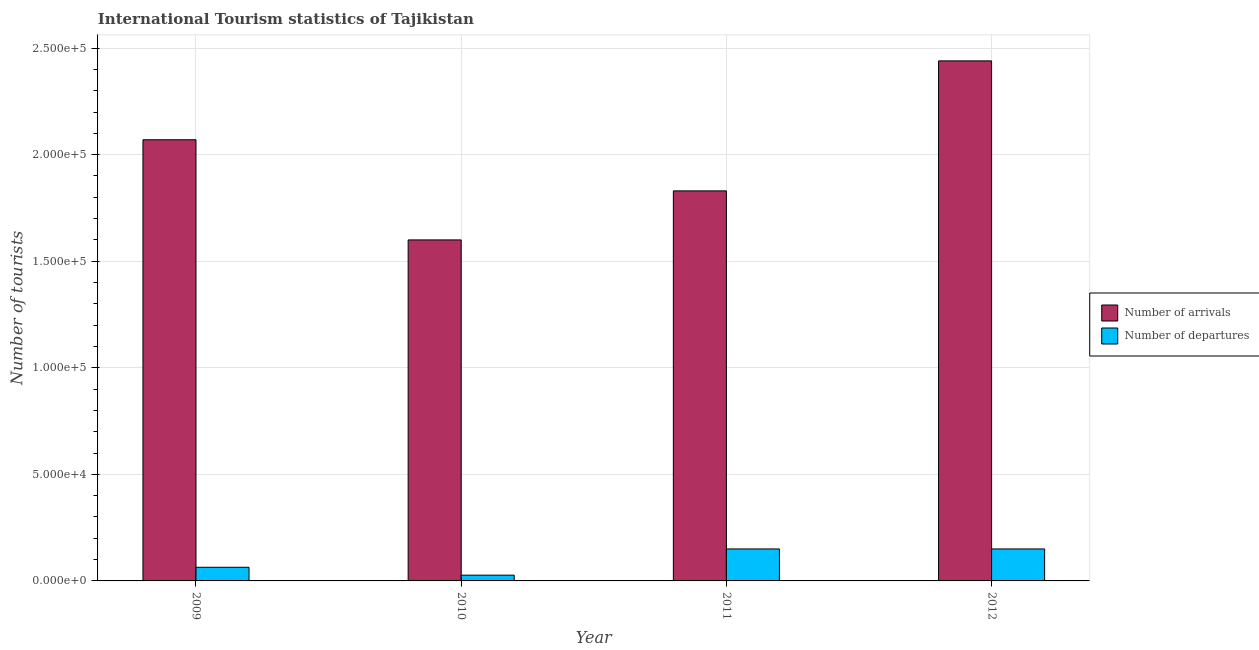How many different coloured bars are there?
Offer a very short reply. 2. Are the number of bars on each tick of the X-axis equal?
Ensure brevity in your answer.  Yes. How many bars are there on the 1st tick from the left?
Offer a terse response. 2. How many bars are there on the 4th tick from the right?
Provide a short and direct response. 2. What is the label of the 4th group of bars from the left?
Make the answer very short. 2012. In how many cases, is the number of bars for a given year not equal to the number of legend labels?
Make the answer very short. 0. What is the number of tourist departures in 2009?
Your answer should be compact. 6400. Across all years, what is the maximum number of tourist arrivals?
Your response must be concise. 2.44e+05. Across all years, what is the minimum number of tourist arrivals?
Offer a very short reply. 1.60e+05. In which year was the number of tourist arrivals maximum?
Ensure brevity in your answer.  2012. In which year was the number of tourist arrivals minimum?
Offer a very short reply. 2010. What is the total number of tourist departures in the graph?
Keep it short and to the point. 3.91e+04. What is the difference between the number of tourist departures in 2010 and that in 2012?
Ensure brevity in your answer.  -1.23e+04. What is the difference between the number of tourist arrivals in 2012 and the number of tourist departures in 2010?
Provide a short and direct response. 8.40e+04. What is the average number of tourist arrivals per year?
Make the answer very short. 1.98e+05. In the year 2010, what is the difference between the number of tourist departures and number of tourist arrivals?
Give a very brief answer. 0. In how many years, is the number of tourist arrivals greater than 70000?
Give a very brief answer. 4. What is the ratio of the number of tourist departures in 2009 to that in 2012?
Your answer should be compact. 0.43. Is the number of tourist arrivals in 2010 less than that in 2012?
Offer a terse response. Yes. What is the difference between the highest and the second highest number of tourist arrivals?
Your response must be concise. 3.70e+04. What is the difference between the highest and the lowest number of tourist departures?
Ensure brevity in your answer.  1.23e+04. What does the 2nd bar from the left in 2010 represents?
Provide a short and direct response. Number of departures. What does the 1st bar from the right in 2012 represents?
Keep it short and to the point. Number of departures. How many years are there in the graph?
Provide a succinct answer. 4. What is the difference between two consecutive major ticks on the Y-axis?
Your response must be concise. 5.00e+04. Are the values on the major ticks of Y-axis written in scientific E-notation?
Provide a short and direct response. Yes. How are the legend labels stacked?
Keep it short and to the point. Vertical. What is the title of the graph?
Ensure brevity in your answer.  International Tourism statistics of Tajikistan. Does "Females" appear as one of the legend labels in the graph?
Your answer should be compact. No. What is the label or title of the Y-axis?
Offer a very short reply. Number of tourists. What is the Number of tourists in Number of arrivals in 2009?
Your response must be concise. 2.07e+05. What is the Number of tourists of Number of departures in 2009?
Offer a terse response. 6400. What is the Number of tourists of Number of arrivals in 2010?
Provide a succinct answer. 1.60e+05. What is the Number of tourists in Number of departures in 2010?
Your answer should be compact. 2700. What is the Number of tourists in Number of arrivals in 2011?
Offer a terse response. 1.83e+05. What is the Number of tourists in Number of departures in 2011?
Provide a succinct answer. 1.50e+04. What is the Number of tourists of Number of arrivals in 2012?
Your answer should be compact. 2.44e+05. What is the Number of tourists in Number of departures in 2012?
Offer a terse response. 1.50e+04. Across all years, what is the maximum Number of tourists of Number of arrivals?
Offer a very short reply. 2.44e+05. Across all years, what is the maximum Number of tourists of Number of departures?
Ensure brevity in your answer.  1.50e+04. Across all years, what is the minimum Number of tourists of Number of arrivals?
Ensure brevity in your answer.  1.60e+05. Across all years, what is the minimum Number of tourists of Number of departures?
Provide a short and direct response. 2700. What is the total Number of tourists in Number of arrivals in the graph?
Ensure brevity in your answer.  7.94e+05. What is the total Number of tourists of Number of departures in the graph?
Your answer should be compact. 3.91e+04. What is the difference between the Number of tourists in Number of arrivals in 2009 and that in 2010?
Give a very brief answer. 4.70e+04. What is the difference between the Number of tourists of Number of departures in 2009 and that in 2010?
Offer a terse response. 3700. What is the difference between the Number of tourists in Number of arrivals in 2009 and that in 2011?
Ensure brevity in your answer.  2.40e+04. What is the difference between the Number of tourists in Number of departures in 2009 and that in 2011?
Keep it short and to the point. -8600. What is the difference between the Number of tourists in Number of arrivals in 2009 and that in 2012?
Give a very brief answer. -3.70e+04. What is the difference between the Number of tourists of Number of departures in 2009 and that in 2012?
Make the answer very short. -8600. What is the difference between the Number of tourists in Number of arrivals in 2010 and that in 2011?
Your answer should be compact. -2.30e+04. What is the difference between the Number of tourists in Number of departures in 2010 and that in 2011?
Give a very brief answer. -1.23e+04. What is the difference between the Number of tourists in Number of arrivals in 2010 and that in 2012?
Provide a short and direct response. -8.40e+04. What is the difference between the Number of tourists of Number of departures in 2010 and that in 2012?
Provide a short and direct response. -1.23e+04. What is the difference between the Number of tourists of Number of arrivals in 2011 and that in 2012?
Your answer should be compact. -6.10e+04. What is the difference between the Number of tourists in Number of arrivals in 2009 and the Number of tourists in Number of departures in 2010?
Keep it short and to the point. 2.04e+05. What is the difference between the Number of tourists in Number of arrivals in 2009 and the Number of tourists in Number of departures in 2011?
Offer a very short reply. 1.92e+05. What is the difference between the Number of tourists in Number of arrivals in 2009 and the Number of tourists in Number of departures in 2012?
Your answer should be very brief. 1.92e+05. What is the difference between the Number of tourists in Number of arrivals in 2010 and the Number of tourists in Number of departures in 2011?
Keep it short and to the point. 1.45e+05. What is the difference between the Number of tourists of Number of arrivals in 2010 and the Number of tourists of Number of departures in 2012?
Provide a short and direct response. 1.45e+05. What is the difference between the Number of tourists in Number of arrivals in 2011 and the Number of tourists in Number of departures in 2012?
Offer a terse response. 1.68e+05. What is the average Number of tourists in Number of arrivals per year?
Provide a succinct answer. 1.98e+05. What is the average Number of tourists in Number of departures per year?
Offer a very short reply. 9775. In the year 2009, what is the difference between the Number of tourists of Number of arrivals and Number of tourists of Number of departures?
Give a very brief answer. 2.01e+05. In the year 2010, what is the difference between the Number of tourists of Number of arrivals and Number of tourists of Number of departures?
Provide a short and direct response. 1.57e+05. In the year 2011, what is the difference between the Number of tourists of Number of arrivals and Number of tourists of Number of departures?
Offer a very short reply. 1.68e+05. In the year 2012, what is the difference between the Number of tourists in Number of arrivals and Number of tourists in Number of departures?
Provide a succinct answer. 2.29e+05. What is the ratio of the Number of tourists in Number of arrivals in 2009 to that in 2010?
Give a very brief answer. 1.29. What is the ratio of the Number of tourists of Number of departures in 2009 to that in 2010?
Keep it short and to the point. 2.37. What is the ratio of the Number of tourists of Number of arrivals in 2009 to that in 2011?
Make the answer very short. 1.13. What is the ratio of the Number of tourists of Number of departures in 2009 to that in 2011?
Provide a short and direct response. 0.43. What is the ratio of the Number of tourists of Number of arrivals in 2009 to that in 2012?
Offer a very short reply. 0.85. What is the ratio of the Number of tourists of Number of departures in 2009 to that in 2012?
Ensure brevity in your answer.  0.43. What is the ratio of the Number of tourists in Number of arrivals in 2010 to that in 2011?
Give a very brief answer. 0.87. What is the ratio of the Number of tourists of Number of departures in 2010 to that in 2011?
Offer a terse response. 0.18. What is the ratio of the Number of tourists in Number of arrivals in 2010 to that in 2012?
Provide a short and direct response. 0.66. What is the ratio of the Number of tourists in Number of departures in 2010 to that in 2012?
Your response must be concise. 0.18. What is the ratio of the Number of tourists in Number of arrivals in 2011 to that in 2012?
Give a very brief answer. 0.75. What is the ratio of the Number of tourists of Number of departures in 2011 to that in 2012?
Give a very brief answer. 1. What is the difference between the highest and the second highest Number of tourists in Number of arrivals?
Give a very brief answer. 3.70e+04. What is the difference between the highest and the second highest Number of tourists of Number of departures?
Your response must be concise. 0. What is the difference between the highest and the lowest Number of tourists of Number of arrivals?
Your answer should be compact. 8.40e+04. What is the difference between the highest and the lowest Number of tourists in Number of departures?
Offer a very short reply. 1.23e+04. 